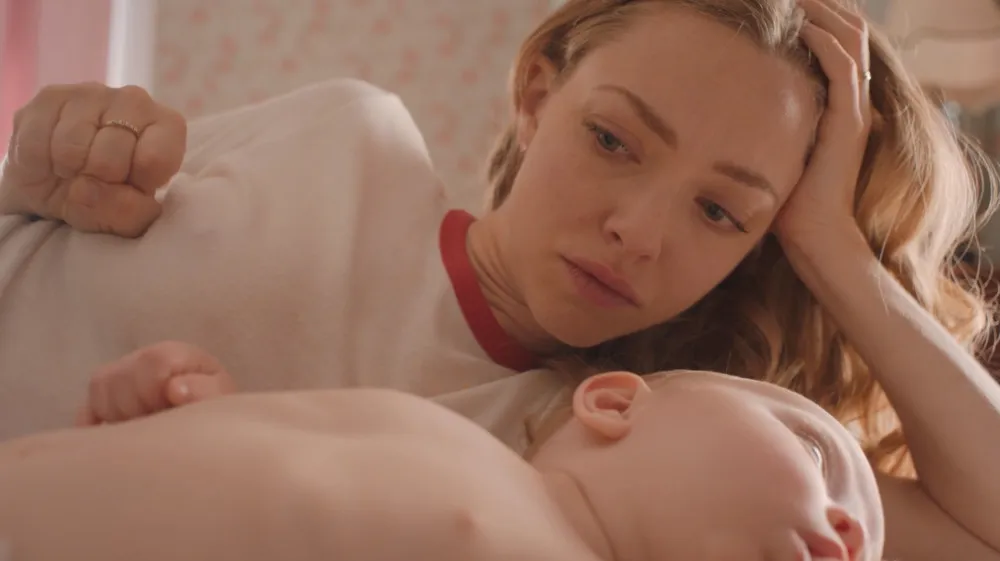What can you tell me about the emotions conveyed by the woman's expression in this image? The woman's expression in the image displays a mix of contemplation and concern. Her furrowed brow and the way her hand rests on her head suggest she is deeply engaged in thought, possibly reflecting on matters of personal significance while ensuring the baby's comfort and peaceful sleep. 